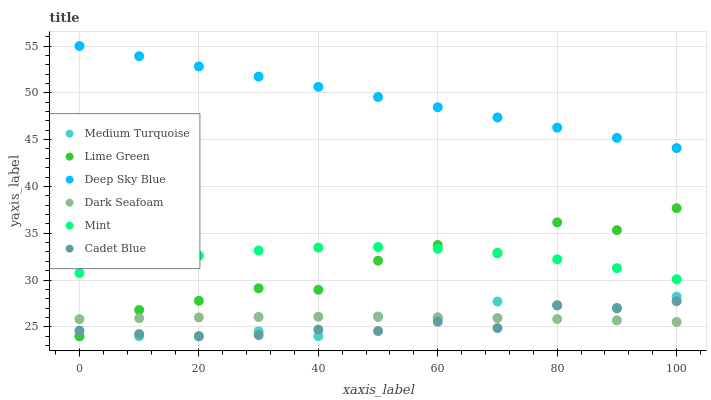Does Cadet Blue have the minimum area under the curve?
Answer yes or no. Yes. Does Deep Sky Blue have the maximum area under the curve?
Answer yes or no. Yes. Does Medium Turquoise have the minimum area under the curve?
Answer yes or no. No. Does Medium Turquoise have the maximum area under the curve?
Answer yes or no. No. Is Deep Sky Blue the smoothest?
Answer yes or no. Yes. Is Lime Green the roughest?
Answer yes or no. Yes. Is Medium Turquoise the smoothest?
Answer yes or no. No. Is Medium Turquoise the roughest?
Answer yes or no. No. Does Cadet Blue have the lowest value?
Answer yes or no. Yes. Does Dark Seafoam have the lowest value?
Answer yes or no. No. Does Deep Sky Blue have the highest value?
Answer yes or no. Yes. Does Medium Turquoise have the highest value?
Answer yes or no. No. Is Cadet Blue less than Mint?
Answer yes or no. Yes. Is Deep Sky Blue greater than Medium Turquoise?
Answer yes or no. Yes. Does Cadet Blue intersect Lime Green?
Answer yes or no. Yes. Is Cadet Blue less than Lime Green?
Answer yes or no. No. Is Cadet Blue greater than Lime Green?
Answer yes or no. No. Does Cadet Blue intersect Mint?
Answer yes or no. No. 